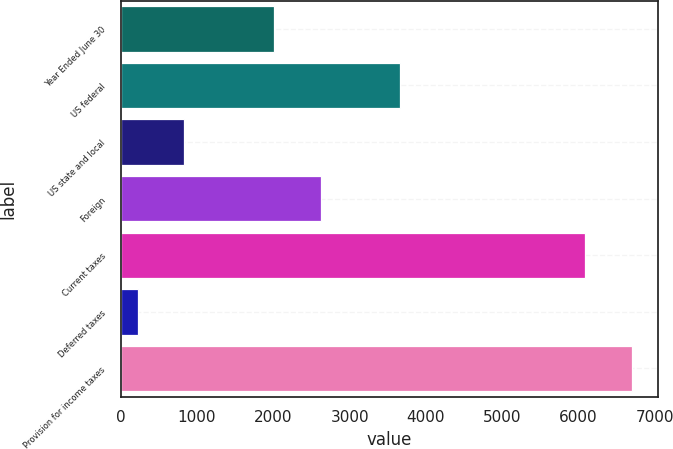<chart> <loc_0><loc_0><loc_500><loc_500><bar_chart><fcel>Year Ended June 30<fcel>US federal<fcel>US state and local<fcel>Foreign<fcel>Current taxes<fcel>Deferred taxes<fcel>Provision for income taxes<nl><fcel>2015<fcel>3661<fcel>833<fcel>2624<fcel>6090<fcel>224<fcel>6699<nl></chart> 